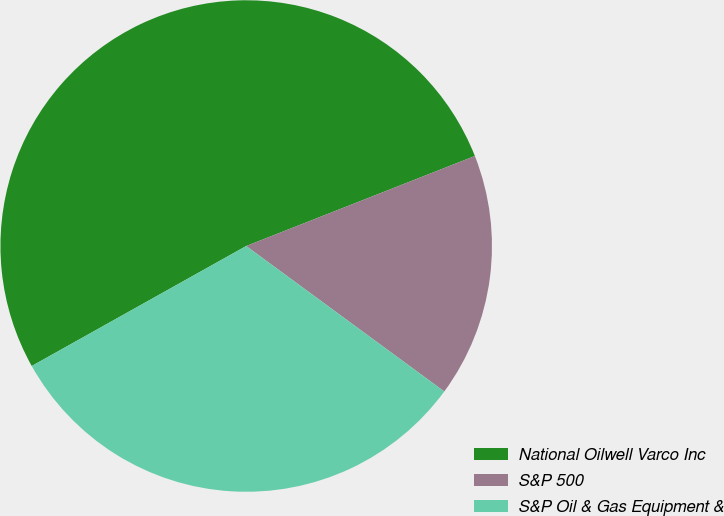<chart> <loc_0><loc_0><loc_500><loc_500><pie_chart><fcel>National Oilwell Varco Inc<fcel>S&P 500<fcel>S&P Oil & Gas Equipment &<nl><fcel>52.15%<fcel>16.05%<fcel>31.8%<nl></chart> 